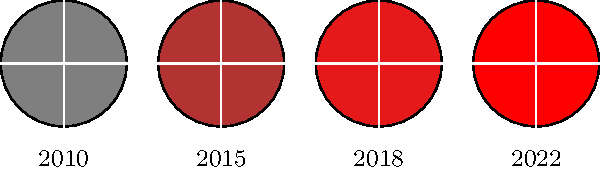How has the color of Alli Linnehan's brand logo evolved from 2010 to 2022, as shown in the series of icons? To understand the evolution of Alli Linnehan's brand logo color, let's analyze the icons chronologically:

1. 2010: The logo is a gray color, represented by RGB(0.5, 0.5, 0.5).
2. 2015: The logo has shifted to a darker red, represented by RGB(0.7, 0.2, 0.2).
3. 2018: The red becomes brighter and more vibrant, represented by RGB(0.9, 0.1, 0.1).
4. 2022: The logo reaches its final form with a pure, bright red color.

This progression shows a clear trend from a neutral gray to an increasingly vivid red, suggesting a brand evolution towards a more bold and energetic identity.
Answer: Gray to vibrant red 